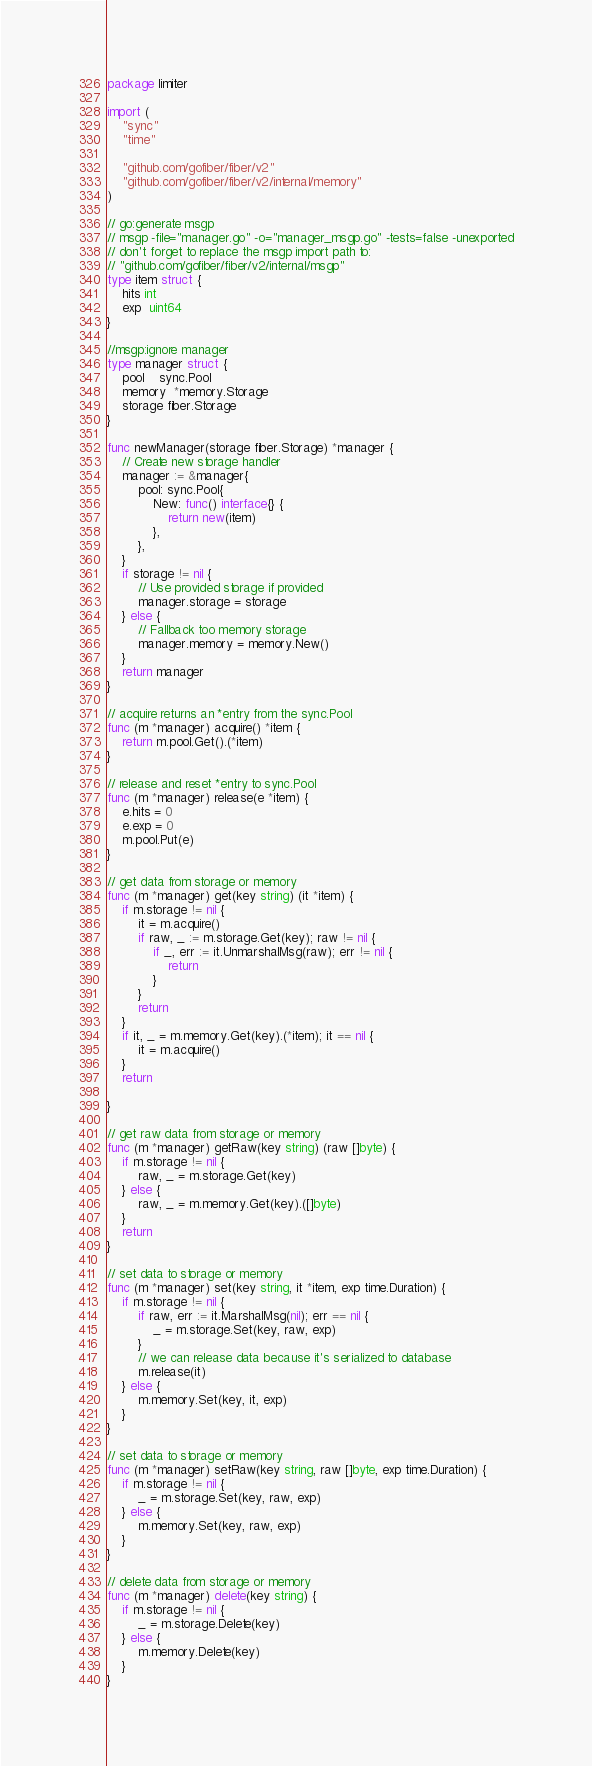Convert code to text. <code><loc_0><loc_0><loc_500><loc_500><_Go_>package limiter

import (
	"sync"
	"time"

	"github.com/gofiber/fiber/v2"
	"github.com/gofiber/fiber/v2/internal/memory"
)

// go:generate msgp
// msgp -file="manager.go" -o="manager_msgp.go" -tests=false -unexported
// don't forget to replace the msgp import path to:
// "github.com/gofiber/fiber/v2/internal/msgp"
type item struct {
	hits int
	exp  uint64
}

//msgp:ignore manager
type manager struct {
	pool    sync.Pool
	memory  *memory.Storage
	storage fiber.Storage
}

func newManager(storage fiber.Storage) *manager {
	// Create new storage handler
	manager := &manager{
		pool: sync.Pool{
			New: func() interface{} {
				return new(item)
			},
		},
	}
	if storage != nil {
		// Use provided storage if provided
		manager.storage = storage
	} else {
		// Fallback too memory storage
		manager.memory = memory.New()
	}
	return manager
}

// acquire returns an *entry from the sync.Pool
func (m *manager) acquire() *item {
	return m.pool.Get().(*item)
}

// release and reset *entry to sync.Pool
func (m *manager) release(e *item) {
	e.hits = 0
	e.exp = 0
	m.pool.Put(e)
}

// get data from storage or memory
func (m *manager) get(key string) (it *item) {
	if m.storage != nil {
		it = m.acquire()
		if raw, _ := m.storage.Get(key); raw != nil {
			if _, err := it.UnmarshalMsg(raw); err != nil {
				return
			}
		}
		return
	}
	if it, _ = m.memory.Get(key).(*item); it == nil {
		it = m.acquire()
	}
	return

}

// get raw data from storage or memory
func (m *manager) getRaw(key string) (raw []byte) {
	if m.storage != nil {
		raw, _ = m.storage.Get(key)
	} else {
		raw, _ = m.memory.Get(key).([]byte)
	}
	return
}

// set data to storage or memory
func (m *manager) set(key string, it *item, exp time.Duration) {
	if m.storage != nil {
		if raw, err := it.MarshalMsg(nil); err == nil {
			_ = m.storage.Set(key, raw, exp)
		}
		// we can release data because it's serialized to database
		m.release(it)
	} else {
		m.memory.Set(key, it, exp)
	}
}

// set data to storage or memory
func (m *manager) setRaw(key string, raw []byte, exp time.Duration) {
	if m.storage != nil {
		_ = m.storage.Set(key, raw, exp)
	} else {
		m.memory.Set(key, raw, exp)
	}
}

// delete data from storage or memory
func (m *manager) delete(key string) {
	if m.storage != nil {
		_ = m.storage.Delete(key)
	} else {
		m.memory.Delete(key)
	}
}
</code> 